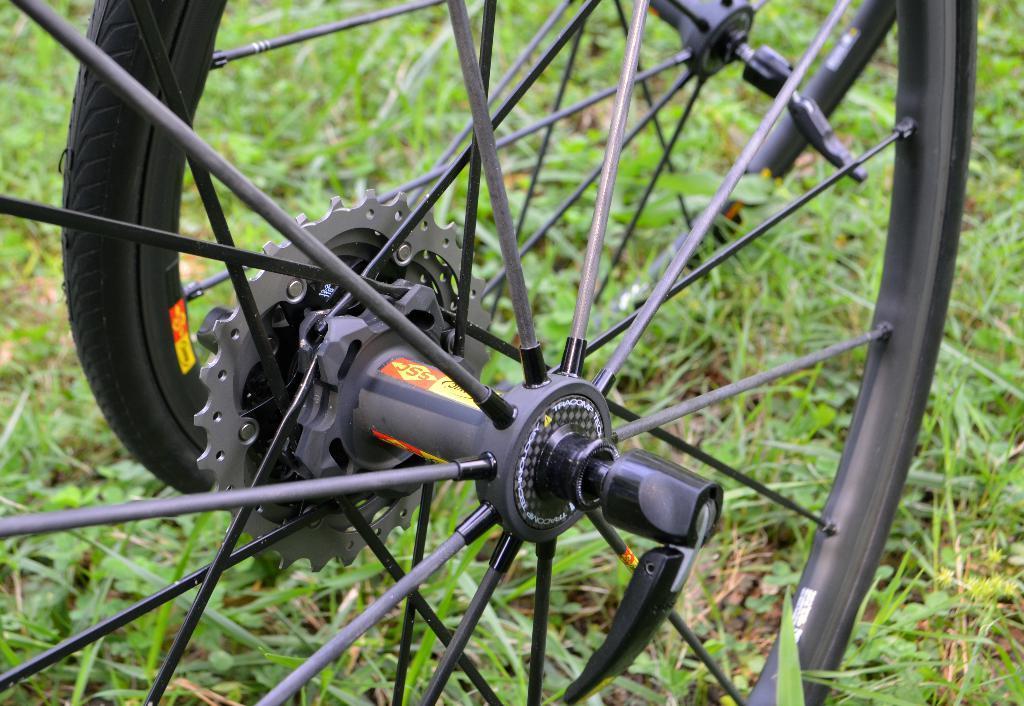In one or two sentences, can you explain what this image depicts? In this picture, we can see wheels, and the ground with grass, plants. 